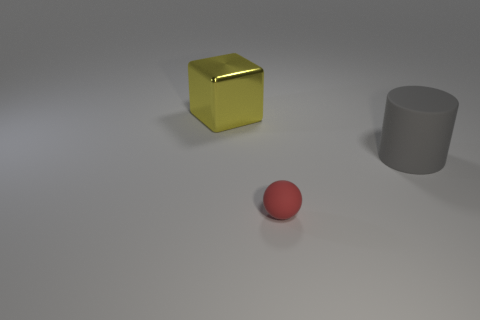What color is the cube that is the same size as the rubber cylinder?
Provide a short and direct response. Yellow. Are there any objects in front of the big object left of the tiny red matte object?
Give a very brief answer. Yes. What material is the large thing on the left side of the tiny thing?
Make the answer very short. Metal. Do the big thing that is in front of the large yellow thing and the thing that is in front of the big gray matte cylinder have the same material?
Provide a succinct answer. Yes. Are there an equal number of things that are behind the small red thing and large yellow blocks in front of the shiny block?
Keep it short and to the point. No. How many cylinders are the same material as the small red thing?
Offer a terse response. 1. What is the size of the thing in front of the matte thing to the right of the small rubber ball?
Your response must be concise. Small. Are there the same number of large matte things in front of the small rubber object and large blue shiny objects?
Provide a succinct answer. Yes. Are the ball that is in front of the rubber cylinder and the big gray thing made of the same material?
Provide a short and direct response. Yes. How many large things are either gray things or yellow shiny blocks?
Provide a succinct answer. 2. 